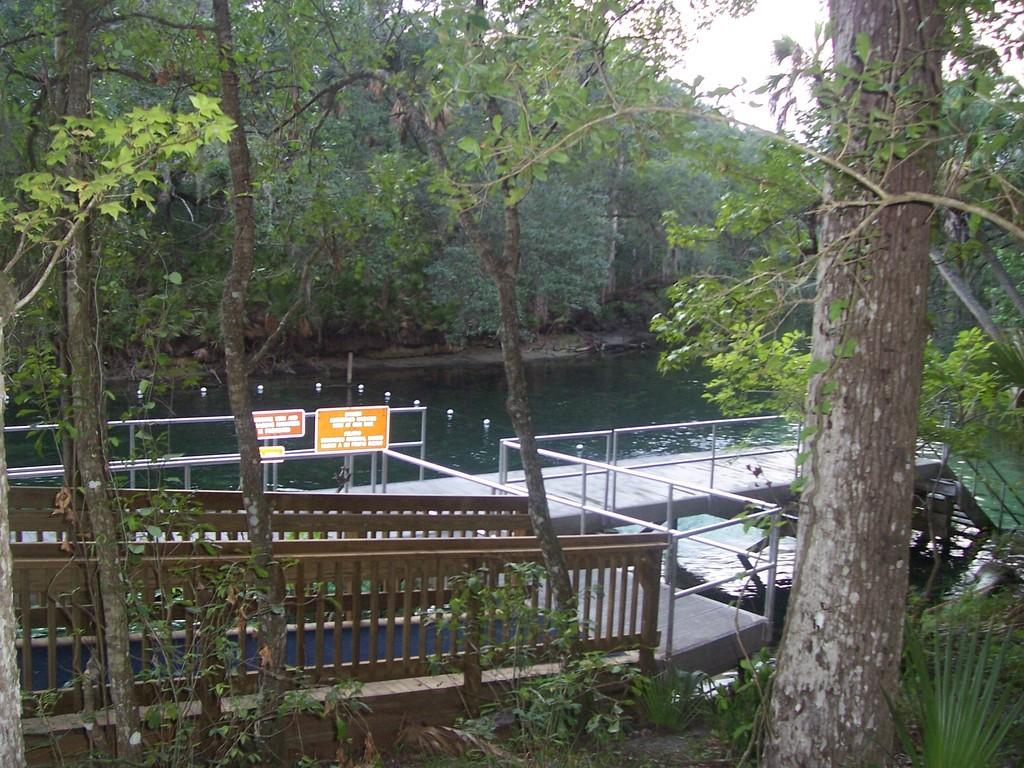What type of natural body of water is present in the image? There is a lake in the image. What type of plant life can be seen in the image? There is a tree in the image. What type of structure is present in the image that allows people to cross the lake? There is a bridge in the image. What type of information might be conveyed by the sign boards in the image? The sign boards in the image might convey information about directions, warnings, or other notices. What is visible at the top of the image? The sky is visible in the image. How many sacks are being used to join the tree and the bridge in the image? There are no sacks present in the image, nor are they being used to join the tree and the bridge. What type of seat can be seen on the bridge in the image? There is no seat present on the bridge in the image. 